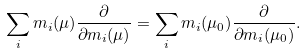Convert formula to latex. <formula><loc_0><loc_0><loc_500><loc_500>\sum _ { i } m _ { i } ( \mu ) \frac { \partial } { \partial m _ { i } ( \mu ) } = \sum _ { i } m _ { i } ( \mu _ { 0 } ) \frac { \partial } { \partial m _ { i } ( \mu _ { 0 } ) } .</formula> 